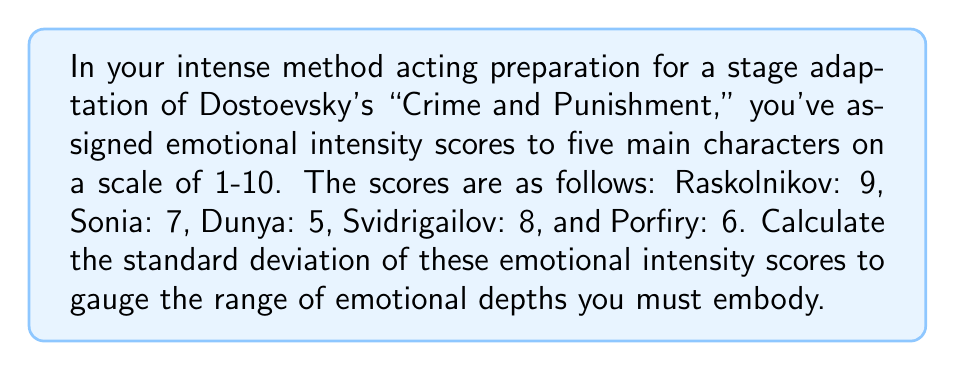Solve this math problem. To calculate the standard deviation, we'll follow these steps:

1. Calculate the mean ($\mu$) of the scores:
   $$\mu = \frac{9 + 7 + 5 + 8 + 6}{5} = 7$$

2. Calculate the squared differences from the mean:
   Raskolnikov: $(9 - 7)^2 = 4$
   Sonia: $(7 - 7)^2 = 0$
   Dunya: $(5 - 7)^2 = 4$
   Svidrigailov: $(8 - 7)^2 = 1$
   Porfiry: $(6 - 7)^2 = 1$

3. Calculate the variance ($\sigma^2$):
   $$\sigma^2 = \frac{4 + 0 + 4 + 1 + 1}{5} = 2$$

4. Calculate the standard deviation ($\sigma$):
   $$\sigma = \sqrt{\sigma^2} = \sqrt{2} \approx 1.414$$

Therefore, the standard deviation of the emotional intensity scores is approximately 1.414.
Answer: $\sqrt{2} \approx 1.414$ 